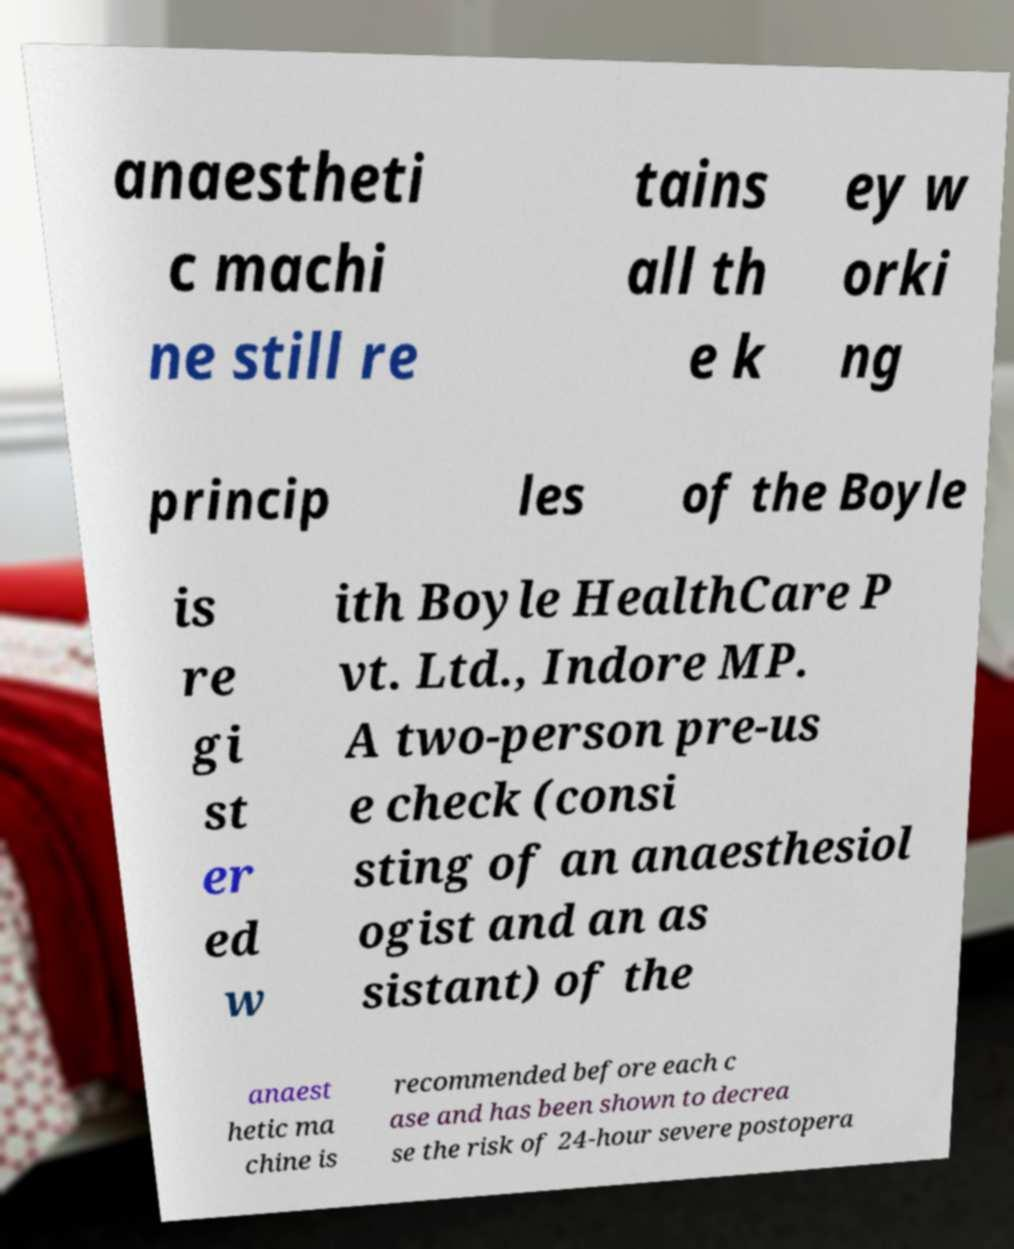Please read and relay the text visible in this image. What does it say? anaestheti c machi ne still re tains all th e k ey w orki ng princip les of the Boyle is re gi st er ed w ith Boyle HealthCare P vt. Ltd., Indore MP. A two-person pre-us e check (consi sting of an anaesthesiol ogist and an as sistant) of the anaest hetic ma chine is recommended before each c ase and has been shown to decrea se the risk of 24-hour severe postopera 